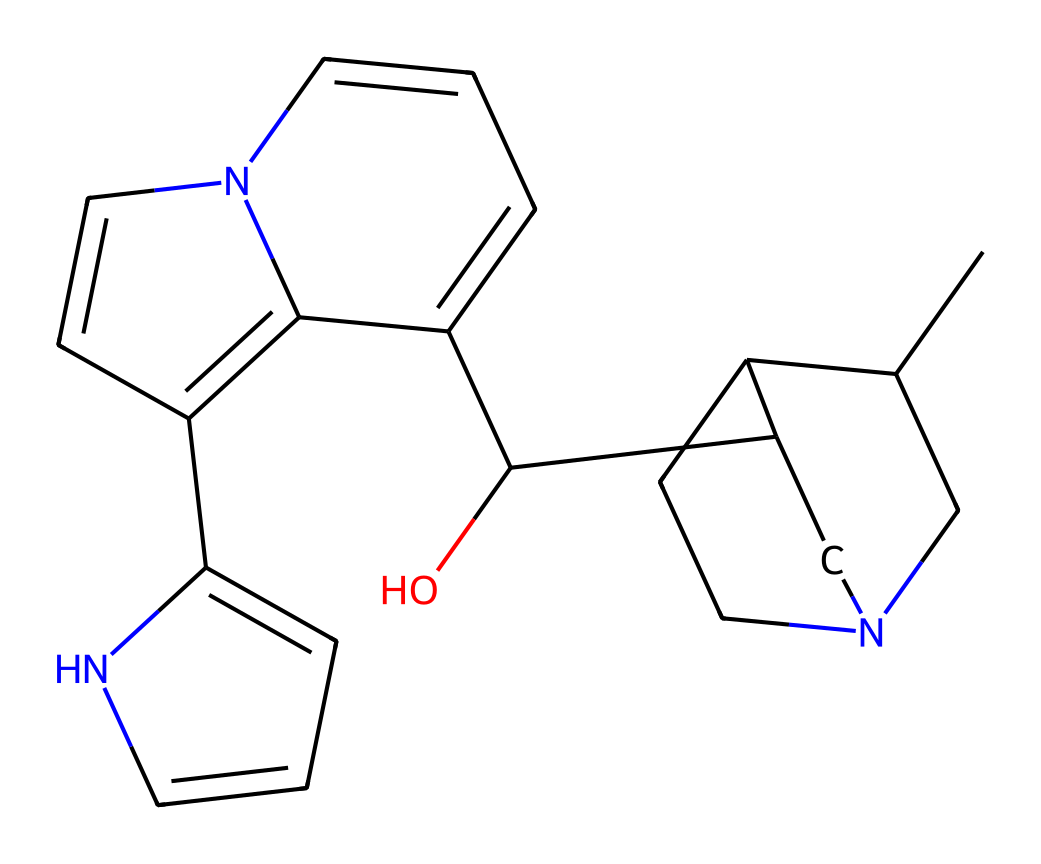What is the total number of carbon atoms in quinine? By analyzing the SMILES representation, we can count the number of 'C' in the formula. There are 20 carbon atoms represented.
Answer: 20 How many nitrogen atoms are in the structure of quinine? In the SMILES representation, we can identify 'N' as the symbol for nitrogen. There are 2 nitrogen atoms present in the structure.
Answer: 2 What type of compound is quinine classified as? Quinine is recognized as an alkaloid due to its nitrogen content and its natural origins from the cinchona bark.
Answer: alkaloid What functional group is indicated by the presence of 'O' in the structure? The 'O' in the SMILES indicates the presence of a hydroxyl group (-OH), which is a common functional group in many natural compounds including alkaloids.
Answer: hydroxyl Which part of the molecule is most likely responsible for its bitter taste? The presence of nitrogen atoms in alkaloids, such as quinine, correlates with the bitter taste characteristic of many alkaloids. Thus, it’s the nitrogen-containing structure that contributes to its taste.
Answer: nitrogen How many rings does the structure of quinine contain? By visualizing the structure or interpreting the SMILES, we can identify that there are 3 rings present in the molecular structure of quinine.
Answer: 3 